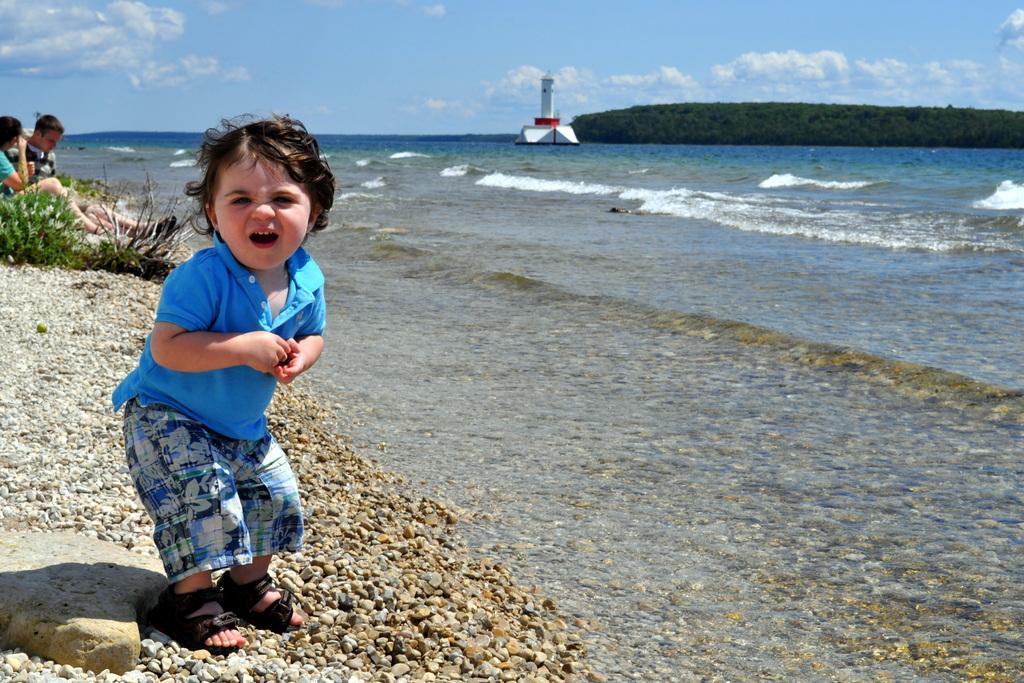Please provide a concise description of this image. In this image I can see a child wearing blue t shirt, short and black footwear is standing, few other persons sitting. I can see few small rocks, a huge rock and a plant. In the background I can see the water, a light house which is white and red in color, few trees and the sky. 